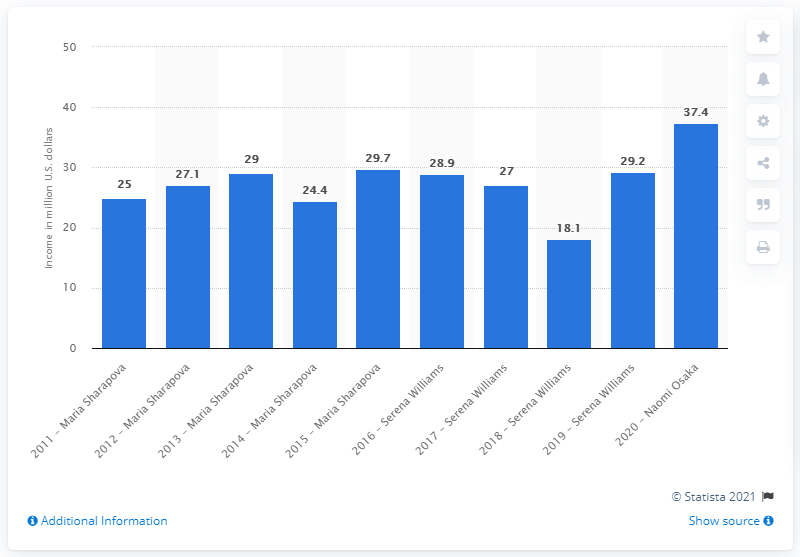Outline some significant characteristics in this image. Naomi Osaka earned $37.4 million in endorsements in 2020, according to reports. 